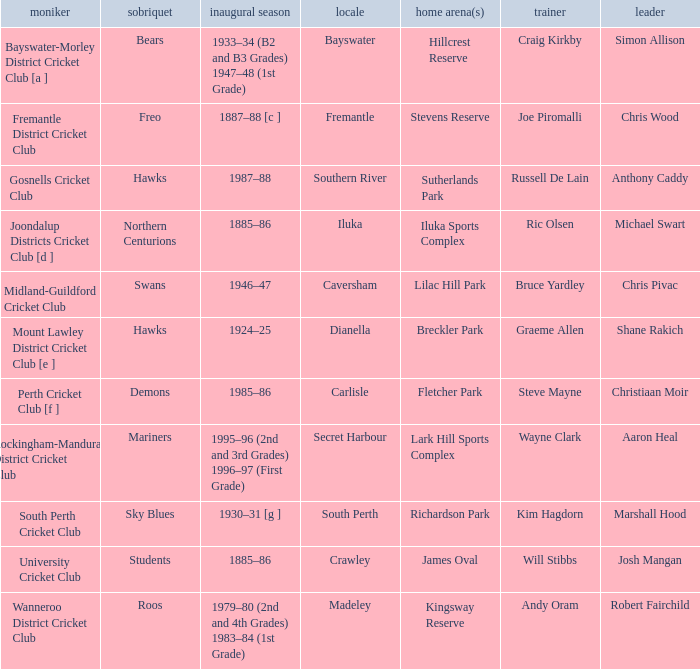What is the dates where Hillcrest Reserve is the home grounds? 1933–34 (B2 and B3 Grades) 1947–48 (1st Grade). 